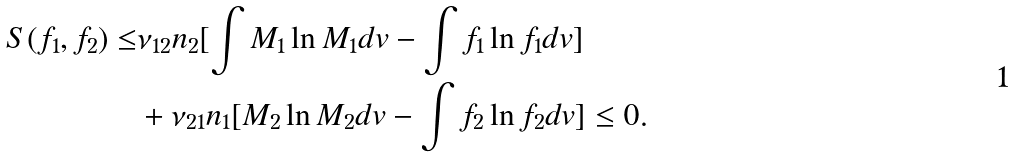<formula> <loc_0><loc_0><loc_500><loc_500>S ( f _ { 1 } , f _ { 2 } ) \leq & \nu _ { 1 2 } n _ { 2 } [ \int M _ { 1 } \ln M _ { 1 } d v - \int f _ { 1 } \ln f _ { 1 } d v ] \\ & + \nu _ { 2 1 } n _ { 1 } [ M _ { 2 } \ln M _ { 2 } d v - \int f _ { 2 } \ln f _ { 2 } d v ] \leq 0 .</formula> 